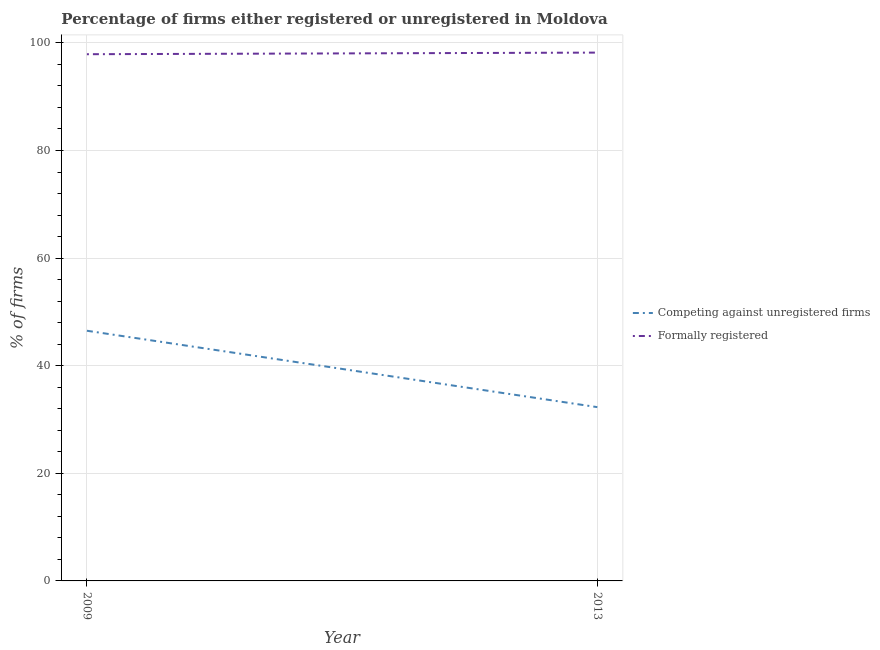How many different coloured lines are there?
Keep it short and to the point. 2. Is the number of lines equal to the number of legend labels?
Give a very brief answer. Yes. What is the percentage of registered firms in 2013?
Provide a succinct answer. 32.3. Across all years, what is the maximum percentage of formally registered firms?
Make the answer very short. 98.2. Across all years, what is the minimum percentage of registered firms?
Ensure brevity in your answer.  32.3. What is the total percentage of formally registered firms in the graph?
Keep it short and to the point. 196.1. What is the difference between the percentage of formally registered firms in 2009 and that in 2013?
Offer a very short reply. -0.3. What is the difference between the percentage of formally registered firms in 2009 and the percentage of registered firms in 2013?
Make the answer very short. 65.6. What is the average percentage of registered firms per year?
Offer a terse response. 39.4. In the year 2013, what is the difference between the percentage of formally registered firms and percentage of registered firms?
Offer a very short reply. 65.9. In how many years, is the percentage of registered firms greater than 88 %?
Provide a short and direct response. 0. What is the ratio of the percentage of registered firms in 2009 to that in 2013?
Provide a short and direct response. 1.44. Does the percentage of formally registered firms monotonically increase over the years?
Offer a very short reply. Yes. Is the percentage of registered firms strictly less than the percentage of formally registered firms over the years?
Provide a succinct answer. Yes. How many lines are there?
Your answer should be very brief. 2. How many years are there in the graph?
Offer a terse response. 2. What is the difference between two consecutive major ticks on the Y-axis?
Provide a succinct answer. 20. Does the graph contain any zero values?
Provide a short and direct response. No. Where does the legend appear in the graph?
Your answer should be compact. Center right. How are the legend labels stacked?
Your response must be concise. Vertical. What is the title of the graph?
Your answer should be compact. Percentage of firms either registered or unregistered in Moldova. Does "Young" appear as one of the legend labels in the graph?
Your answer should be very brief. No. What is the label or title of the Y-axis?
Keep it short and to the point. % of firms. What is the % of firms of Competing against unregistered firms in 2009?
Provide a succinct answer. 46.5. What is the % of firms in Formally registered in 2009?
Offer a very short reply. 97.9. What is the % of firms in Competing against unregistered firms in 2013?
Provide a short and direct response. 32.3. What is the % of firms in Formally registered in 2013?
Provide a succinct answer. 98.2. Across all years, what is the maximum % of firms of Competing against unregistered firms?
Your answer should be very brief. 46.5. Across all years, what is the maximum % of firms in Formally registered?
Offer a terse response. 98.2. Across all years, what is the minimum % of firms in Competing against unregistered firms?
Keep it short and to the point. 32.3. Across all years, what is the minimum % of firms in Formally registered?
Offer a very short reply. 97.9. What is the total % of firms of Competing against unregistered firms in the graph?
Offer a very short reply. 78.8. What is the total % of firms of Formally registered in the graph?
Keep it short and to the point. 196.1. What is the difference between the % of firms in Competing against unregistered firms in 2009 and that in 2013?
Make the answer very short. 14.2. What is the difference between the % of firms of Formally registered in 2009 and that in 2013?
Ensure brevity in your answer.  -0.3. What is the difference between the % of firms in Competing against unregistered firms in 2009 and the % of firms in Formally registered in 2013?
Your response must be concise. -51.7. What is the average % of firms in Competing against unregistered firms per year?
Offer a very short reply. 39.4. What is the average % of firms in Formally registered per year?
Make the answer very short. 98.05. In the year 2009, what is the difference between the % of firms of Competing against unregistered firms and % of firms of Formally registered?
Offer a terse response. -51.4. In the year 2013, what is the difference between the % of firms in Competing against unregistered firms and % of firms in Formally registered?
Offer a very short reply. -65.9. What is the ratio of the % of firms of Competing against unregistered firms in 2009 to that in 2013?
Offer a very short reply. 1.44. What is the ratio of the % of firms in Formally registered in 2009 to that in 2013?
Provide a short and direct response. 1. What is the difference between the highest and the lowest % of firms in Competing against unregistered firms?
Provide a short and direct response. 14.2. What is the difference between the highest and the lowest % of firms of Formally registered?
Make the answer very short. 0.3. 